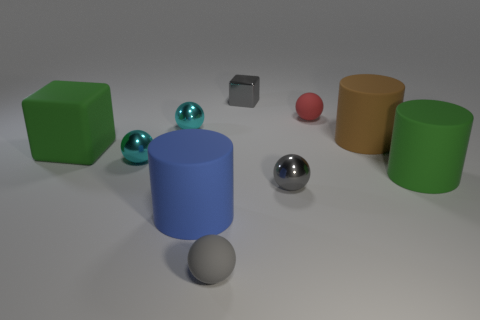Subtract all gray rubber spheres. How many spheres are left? 4 Subtract all red balls. How many balls are left? 4 Subtract 1 spheres. How many spheres are left? 4 Subtract all yellow balls. Subtract all brown cubes. How many balls are left? 5 Subtract all blocks. How many objects are left? 8 Add 6 green matte things. How many green matte things exist? 8 Subtract 0 blue blocks. How many objects are left? 10 Subtract all big red things. Subtract all cyan metallic things. How many objects are left? 8 Add 4 big brown rubber cylinders. How many big brown rubber cylinders are left? 5 